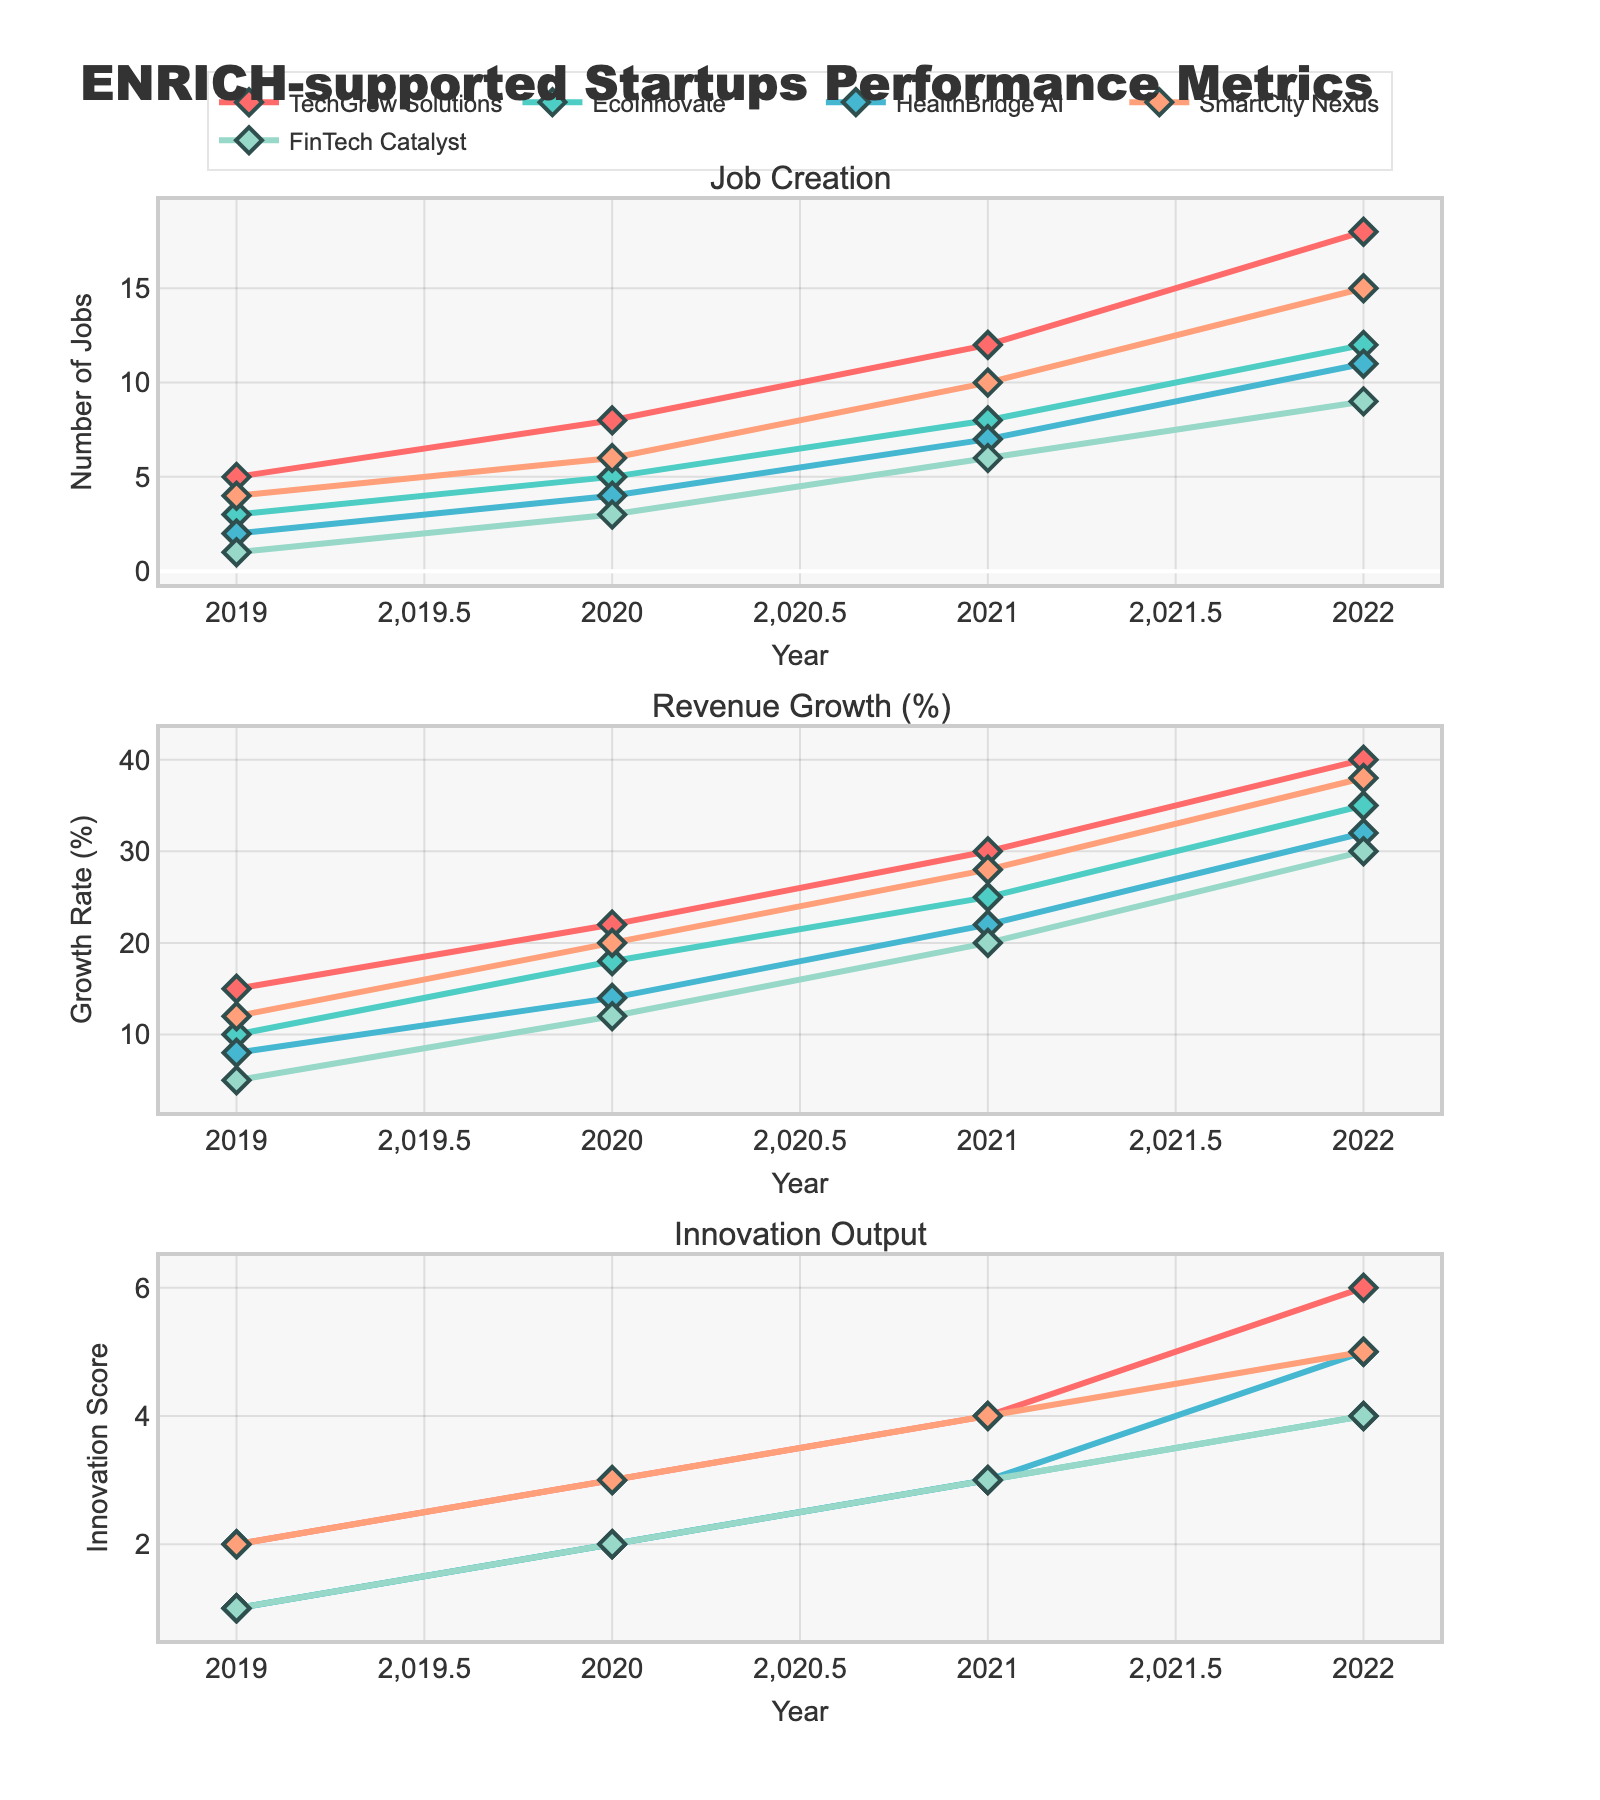What is the title of the figure? The title can be found at the top of the figure, providing an overview of what the figure represents.
Answer: ENRICH-supported Startups Performance Metrics Which company had the lowest job creation in 2019? Look at the Job Creation subplot for 2019 and compare the values across all companies.
Answer: FinTech Catalyst How many jobs did TechGrow Solutions create in 2021? Locate TechGrow Solutions in the Job Creation subplot for the year 2021.
Answer: 12 Which company showed the highest revenue growth percentage in 2022? Look at the Revenue Growth subplot for 2022 and identify the company with the highest value.
Answer: TechGrow Solutions What is the average innovation score for HealthBridge AI over the years? Find the Innovation Output scores for HealthBridge AI for all years and calculate the average. The values are 1, 2, 3, and 5, so (1+2+3+5)/4.
Answer: 2.75 What is the total job creation by EcoInnovate from 2019 to 2022? Sum the job creation numbers for EcoInnovate from 2019 to 2022. The values are 3, 5, 8, and 12, so 3+5+8+12.
Answer: 28 How did revenue growth for SmartCity Nexus change from 2020 to 2021? Look at the Revenue Growth subplot for SmartCity Nexus, noting the values for 2020 and 2021 and then subtract the former from the latter for the change.
Answer: +8% (20% to 28%) Which company had the smallest increase in innovation output from 2019 to 2022? Calculate the difference in innovation output scores from 2019 to 2022 for each company and identify the lowest difference.
Answer: EcoInnovate (3) Compare the job creation trends for HealthBridge AI and FinTech Catalyst. Which company had more stable growth? Look at the Job Creation subplot for both companies over the years and observe the patterns. Identify which one shows a steadier increase.
Answer: HealthBridge AI In which year did SmartCity Nexus show its highest yearly growth in revenue? Find the maximum yearly increase in revenue growth for SmartCity Nexus by comparing each year’s values.
Answer: 2020-2021 